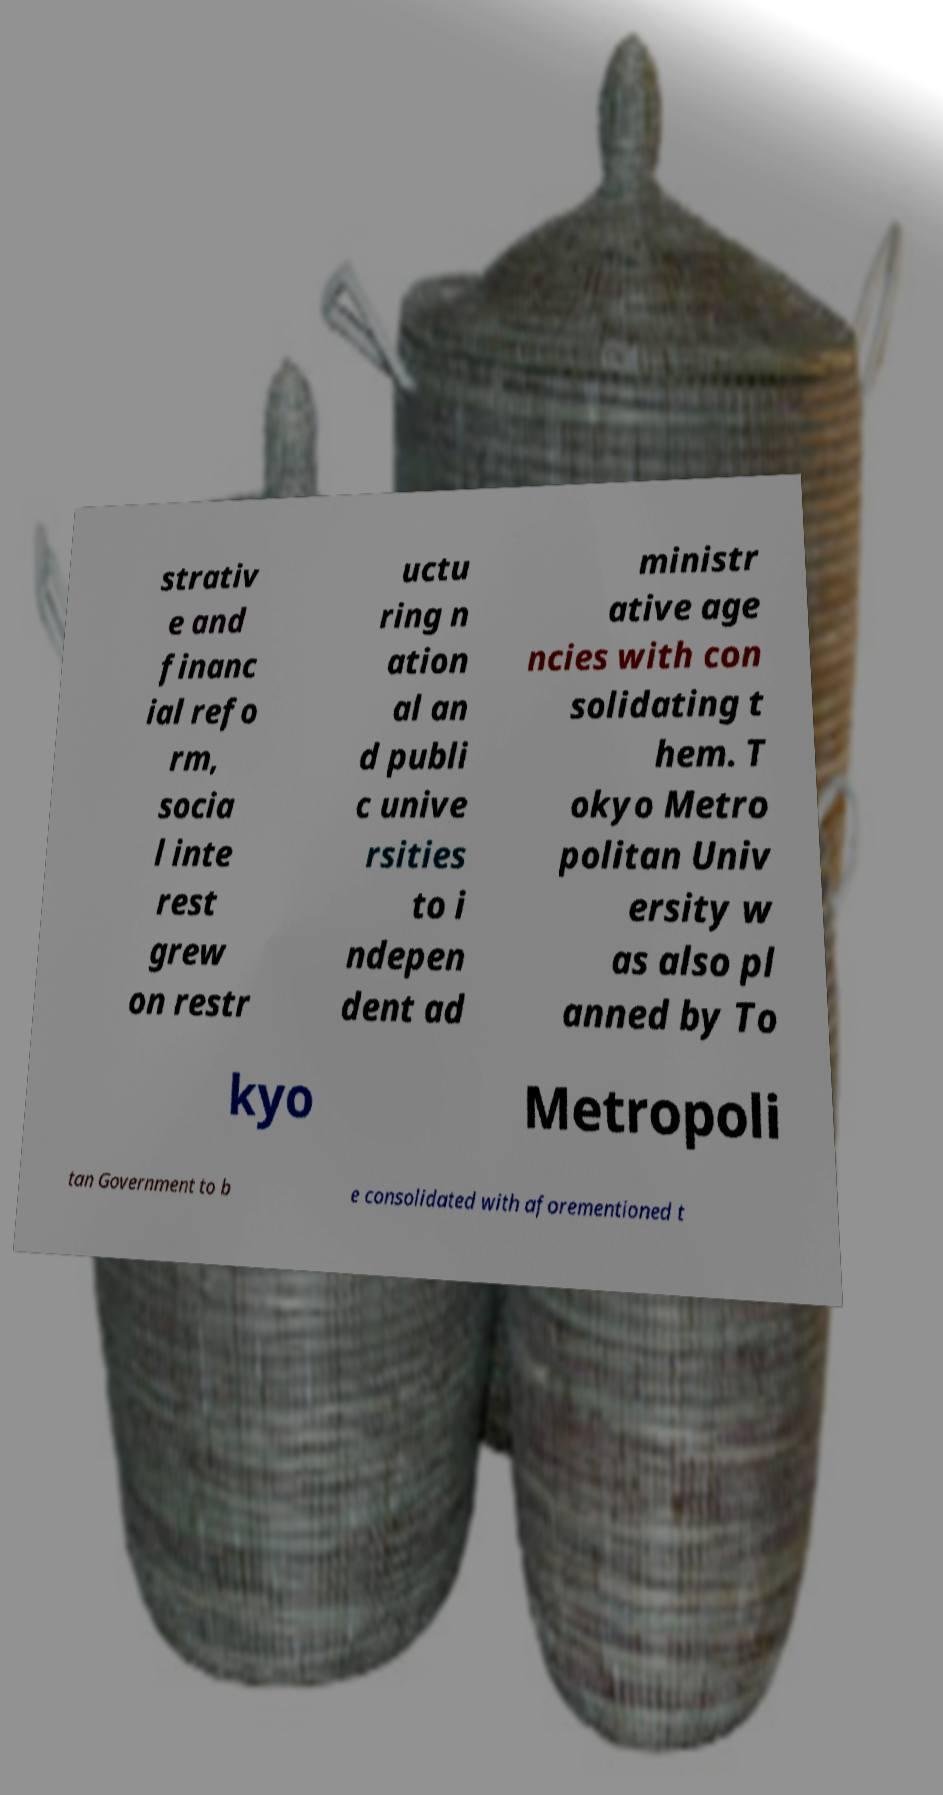What messages or text are displayed in this image? I need them in a readable, typed format. strativ e and financ ial refo rm, socia l inte rest grew on restr uctu ring n ation al an d publi c unive rsities to i ndepen dent ad ministr ative age ncies with con solidating t hem. T okyo Metro politan Univ ersity w as also pl anned by To kyo Metropoli tan Government to b e consolidated with aforementioned t 